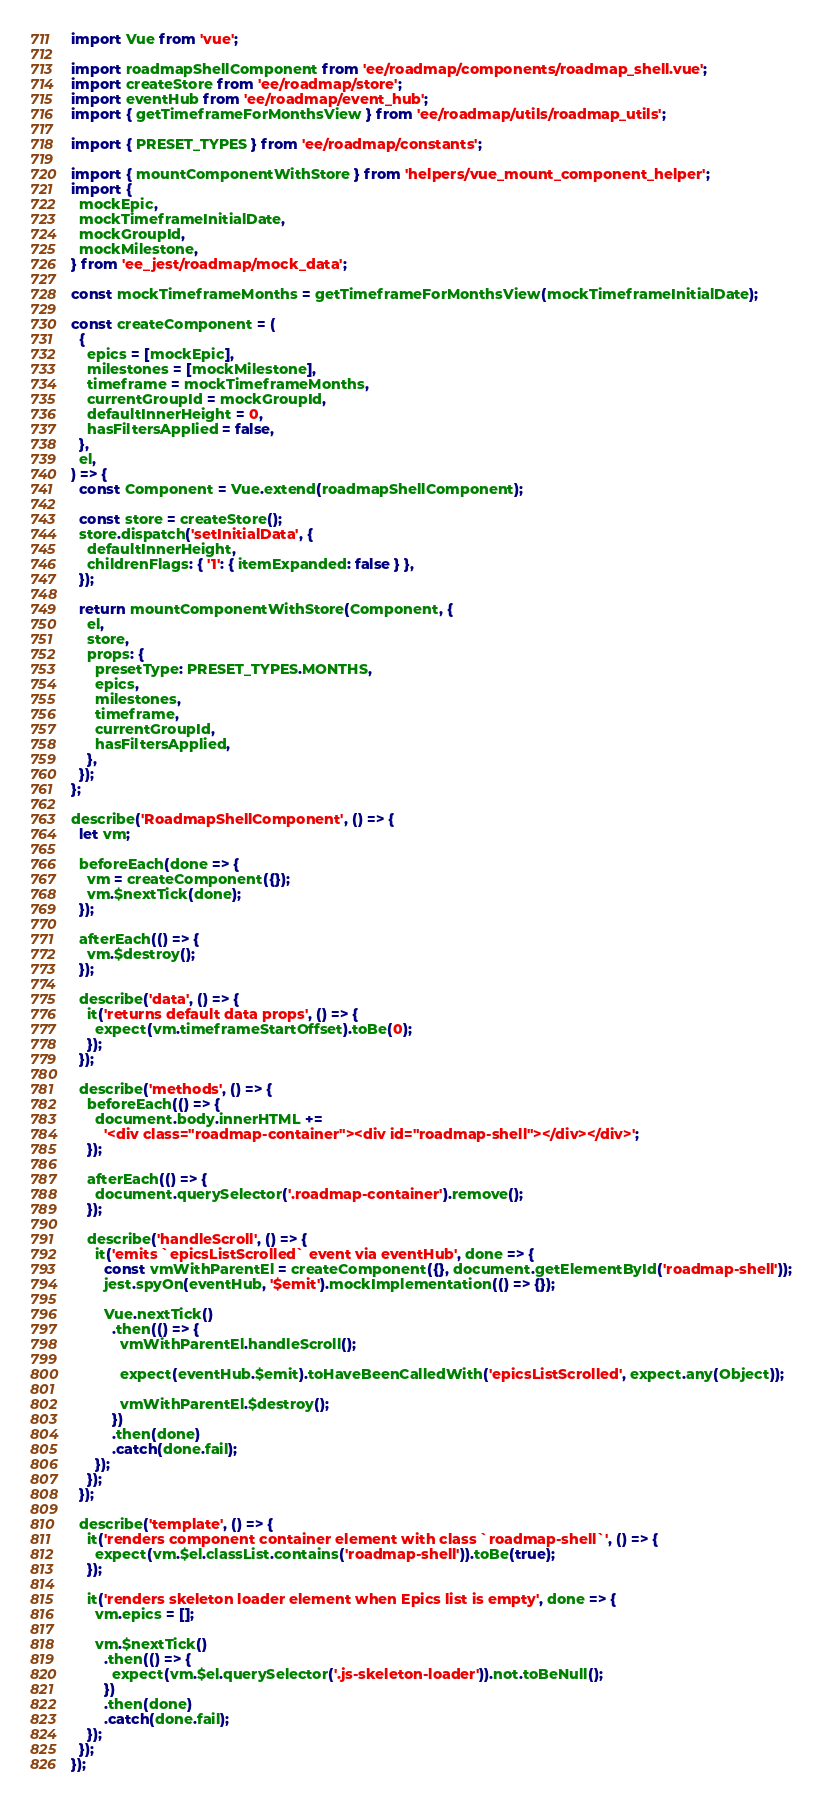<code> <loc_0><loc_0><loc_500><loc_500><_JavaScript_>import Vue from 'vue';

import roadmapShellComponent from 'ee/roadmap/components/roadmap_shell.vue';
import createStore from 'ee/roadmap/store';
import eventHub from 'ee/roadmap/event_hub';
import { getTimeframeForMonthsView } from 'ee/roadmap/utils/roadmap_utils';

import { PRESET_TYPES } from 'ee/roadmap/constants';

import { mountComponentWithStore } from 'helpers/vue_mount_component_helper';
import {
  mockEpic,
  mockTimeframeInitialDate,
  mockGroupId,
  mockMilestone,
} from 'ee_jest/roadmap/mock_data';

const mockTimeframeMonths = getTimeframeForMonthsView(mockTimeframeInitialDate);

const createComponent = (
  {
    epics = [mockEpic],
    milestones = [mockMilestone],
    timeframe = mockTimeframeMonths,
    currentGroupId = mockGroupId,
    defaultInnerHeight = 0,
    hasFiltersApplied = false,
  },
  el,
) => {
  const Component = Vue.extend(roadmapShellComponent);

  const store = createStore();
  store.dispatch('setInitialData', {
    defaultInnerHeight,
    childrenFlags: { '1': { itemExpanded: false } },
  });

  return mountComponentWithStore(Component, {
    el,
    store,
    props: {
      presetType: PRESET_TYPES.MONTHS,
      epics,
      milestones,
      timeframe,
      currentGroupId,
      hasFiltersApplied,
    },
  });
};

describe('RoadmapShellComponent', () => {
  let vm;

  beforeEach(done => {
    vm = createComponent({});
    vm.$nextTick(done);
  });

  afterEach(() => {
    vm.$destroy();
  });

  describe('data', () => {
    it('returns default data props', () => {
      expect(vm.timeframeStartOffset).toBe(0);
    });
  });

  describe('methods', () => {
    beforeEach(() => {
      document.body.innerHTML +=
        '<div class="roadmap-container"><div id="roadmap-shell"></div></div>';
    });

    afterEach(() => {
      document.querySelector('.roadmap-container').remove();
    });

    describe('handleScroll', () => {
      it('emits `epicsListScrolled` event via eventHub', done => {
        const vmWithParentEl = createComponent({}, document.getElementById('roadmap-shell'));
        jest.spyOn(eventHub, '$emit').mockImplementation(() => {});

        Vue.nextTick()
          .then(() => {
            vmWithParentEl.handleScroll();

            expect(eventHub.$emit).toHaveBeenCalledWith('epicsListScrolled', expect.any(Object));

            vmWithParentEl.$destroy();
          })
          .then(done)
          .catch(done.fail);
      });
    });
  });

  describe('template', () => {
    it('renders component container element with class `roadmap-shell`', () => {
      expect(vm.$el.classList.contains('roadmap-shell')).toBe(true);
    });

    it('renders skeleton loader element when Epics list is empty', done => {
      vm.epics = [];

      vm.$nextTick()
        .then(() => {
          expect(vm.$el.querySelector('.js-skeleton-loader')).not.toBeNull();
        })
        .then(done)
        .catch(done.fail);
    });
  });
});
</code> 